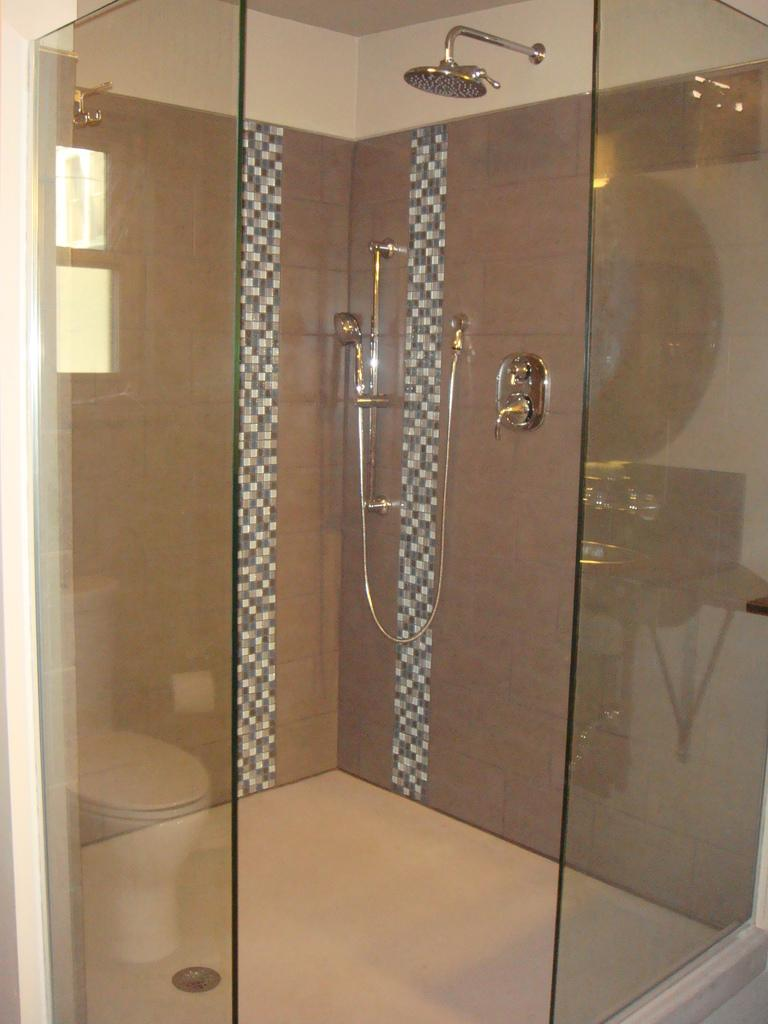What is the main structure in the center of the image? There is a wall, roof, glass, and a bowl toilet in the center of the image. Can you describe the window in the center of the image? There is a window in the center of the image. What type of fixture is present in the center of the image? There are taps in the center of the image. What other objects can be seen in the center of the image? There are a few other objects in the center of the image. How does the quartz contribute to the digestion process in the image? There is no quartz present in the image, and therefore it cannot contribute to any digestion process. 